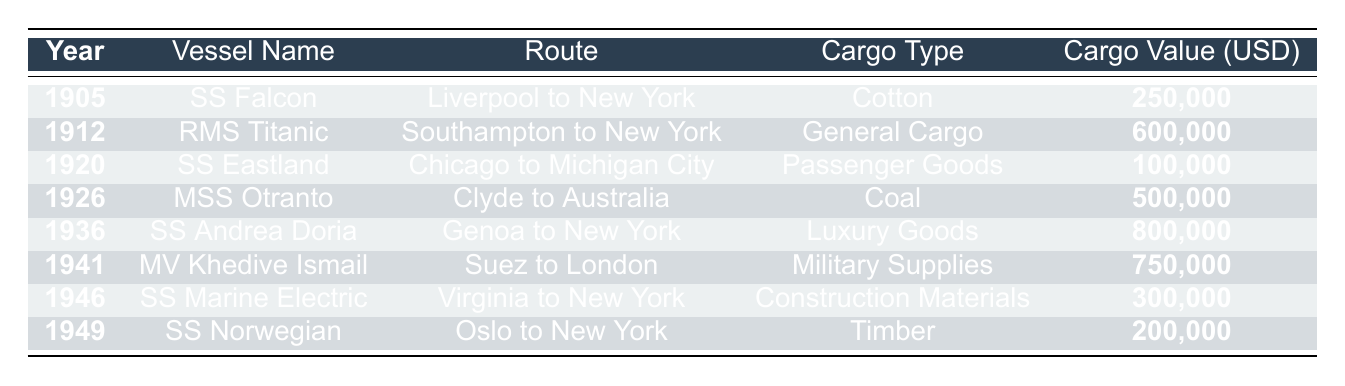What was the highest cargo value lost due to a shipwreck? The table lists multiple shipwrecks with cargo values; the maximum value is found in the row for the SS Andrea Doria, which had a cargo value of 800,000 USD.
Answer: 800,000 How many shipwrecks reported cargo losses greater than 500,000 USD? Looking through the cargo values in the table, the vessel RMS Titanic (600,000) and SS Andrea Doria (800,000) were the only shipwrecks exceeding 500,000 USD. Thus, there are 2 shipwrecks.
Answer: 2 In which year did the shipwreck with the lowest cargo value occur? The cargo values are examined year by year, and the SS Eastland in 1920 reported the lowest cargo value of 100,000 USD.
Answer: 1920 Which route suffered the cargo loss of military supplies during World War II? The only shipwreck related to military supplies is the MV Khedive Ismail; its route was Suez to London.
Answer: Suez to London Was the SS Falcon’s cargo value higher than SS Norwegian’s? Comparing the cargo values, the SS Falcon had a cargo value of 250,000 USD, while the SS Norwegian had 200,000 USD. Since 250,000 is greater than 200,000, the statement is true.
Answer: Yes How much total cargo value was lost from the shipwrecks listed from 1900 to 1950? Summing all the cargo values: 250,000 + 600,000 + 100,000 + 500,000 + 800,000 + 750,000 + 300,000 + 200,000 gives a total of 2,700,000 USD.
Answer: 2,700,000 What was the predominant cargo type lost during the shipwrecks listed? Reviewing the cargo types, Coal (MSS Otranto), Military Supplies (MV Khedive Ismail), and Luxury Goods (SS Andrea Doria) were among the higher values, but General Cargo from RMS Titanic was also significant. There’s no single "predominant" type but luxury goods had the highest single value.
Answer: Luxury Goods Which two shipwrecks occurred in the 1940s? Referring to the years in the table, MV Khedive Ismail occurred in 1941 and SS Marine Electric in 1946, making them the two shipwrecks in the 1940s.
Answer: MV Khedive Ismail and SS Marine Electric What was the cargo type of the shipwreck that occurred in 1926? The vessel involved in the 1926 wreck was MSS Otranto, and the cargo type listed is Coal.
Answer: Coal Did any shipwrecks report total loss of cargo? The SS Titanic and SS Marine Electric both noted total cargo loss; thus the answer is yes.
Answer: Yes How does the average cargo value from the shipwrecks compare with that of the SS Falcon? The average cargo value is calculated as (250,000 + 600,000 + 100,000 + 500,000 + 800,000 + 750,000 + 300,000 + 200,000) / 8 = 337,500. The SS Falcon's value (250,000) is less than the average.
Answer: Less than average 